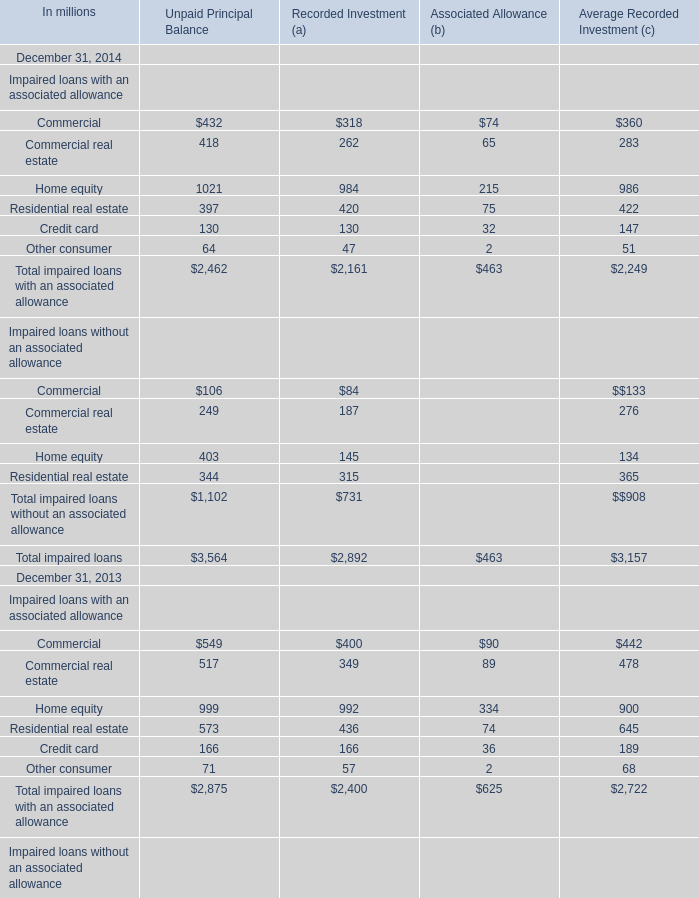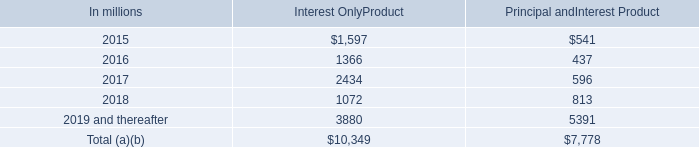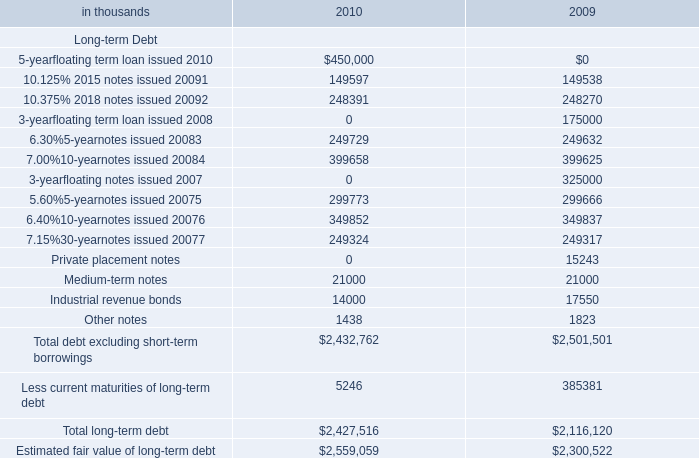as of dec 31 , 2014 , how big is the total loan portfolio , in billions? 
Computations: ((34.7 / 17) * 100)
Answer: 204.11765. 